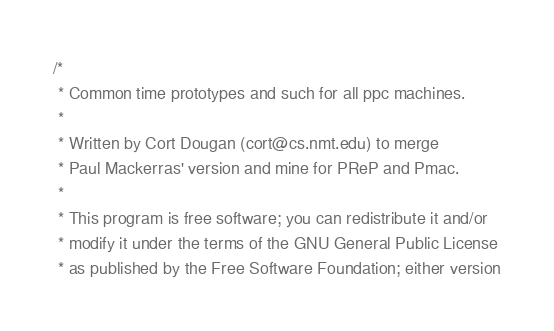Convert code to text. <code><loc_0><loc_0><loc_500><loc_500><_C_>/*
 * Common time prototypes and such for all ppc machines.
 *
 * Written by Cort Dougan (cort@cs.nmt.edu) to merge
 * Paul Mackerras' version and mine for PReP and Pmac.
 *
 * This program is free software; you can redistribute it and/or
 * modify it under the terms of the GNU General Public License
 * as published by the Free Software Foundation; either version</code> 